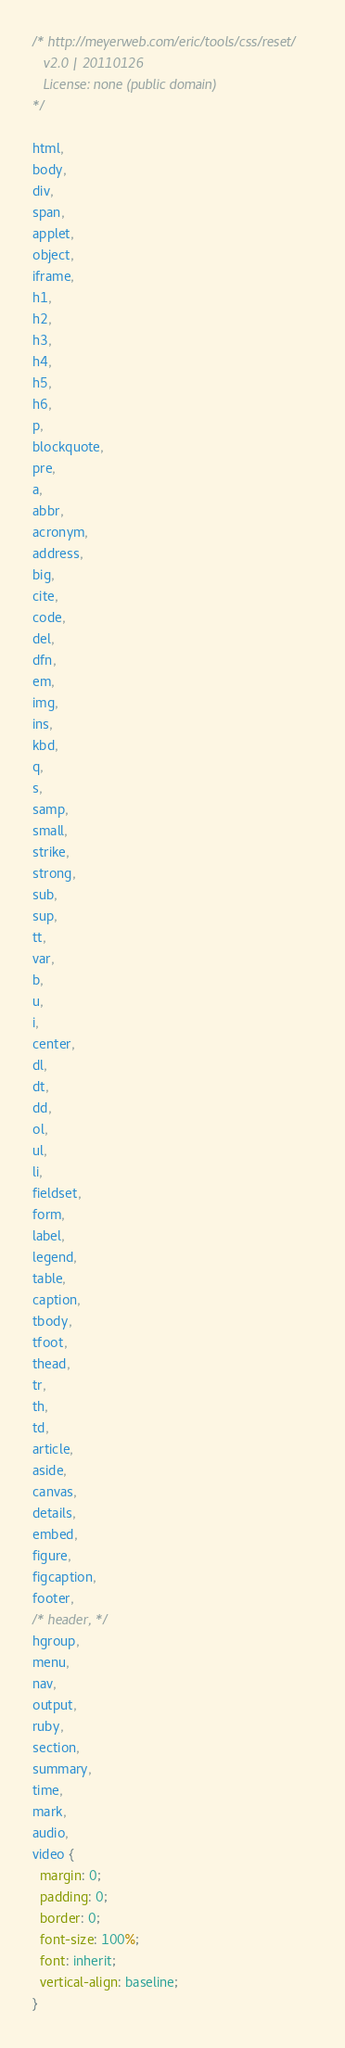Convert code to text. <code><loc_0><loc_0><loc_500><loc_500><_CSS_>/* http://meyerweb.com/eric/tools/css/reset/ 
   v2.0 | 20110126
   License: none (public domain)
*/

html,
body,
div,
span,
applet,
object,
iframe,
h1,
h2,
h3,
h4,
h5,
h6,
p,
blockquote,
pre,
a,
abbr,
acronym,
address,
big,
cite,
code,
del,
dfn,
em,
img,
ins,
kbd,
q,
s,
samp,
small,
strike,
strong,
sub,
sup,
tt,
var,
b,
u,
i,
center,
dl,
dt,
dd,
ol,
ul,
li,
fieldset,
form,
label,
legend,
table,
caption,
tbody,
tfoot,
thead,
tr,
th,
td,
article,
aside,
canvas,
details,
embed,
figure,
figcaption,
footer,
/* header, */
hgroup,
menu,
nav,
output,
ruby,
section,
summary,
time,
mark,
audio,
video {
  margin: 0;
  padding: 0;
  border: 0;
  font-size: 100%;
  font: inherit;
  vertical-align: baseline;
}</code> 